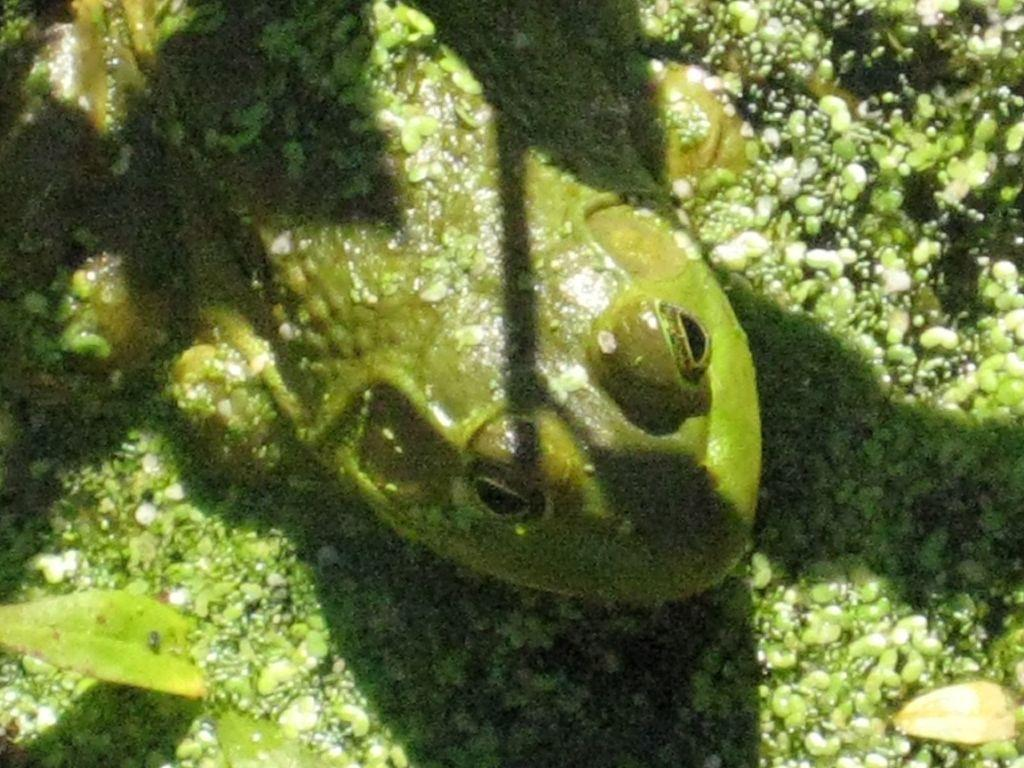What animal is present in the image? There is a frog in the image. Where is the frog located? The frog is in the water. What type of vegetation can be seen in the image? There are water plants in the image. What type of hope can be seen in the image? There is no reference to hope in the image; it features a frog in the water with water plants. 